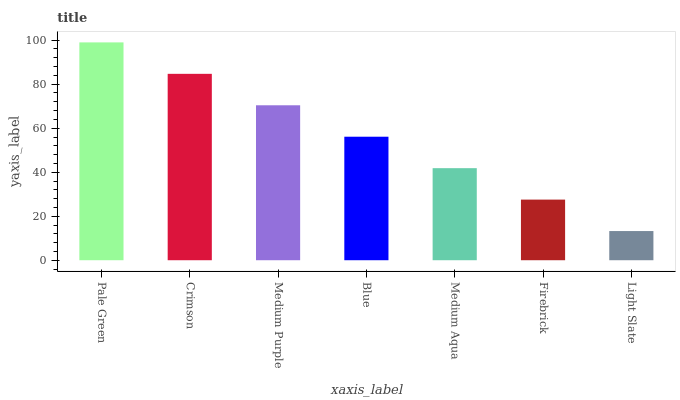Is Light Slate the minimum?
Answer yes or no. Yes. Is Pale Green the maximum?
Answer yes or no. Yes. Is Crimson the minimum?
Answer yes or no. No. Is Crimson the maximum?
Answer yes or no. No. Is Pale Green greater than Crimson?
Answer yes or no. Yes. Is Crimson less than Pale Green?
Answer yes or no. Yes. Is Crimson greater than Pale Green?
Answer yes or no. No. Is Pale Green less than Crimson?
Answer yes or no. No. Is Blue the high median?
Answer yes or no. Yes. Is Blue the low median?
Answer yes or no. Yes. Is Medium Aqua the high median?
Answer yes or no. No. Is Medium Purple the low median?
Answer yes or no. No. 